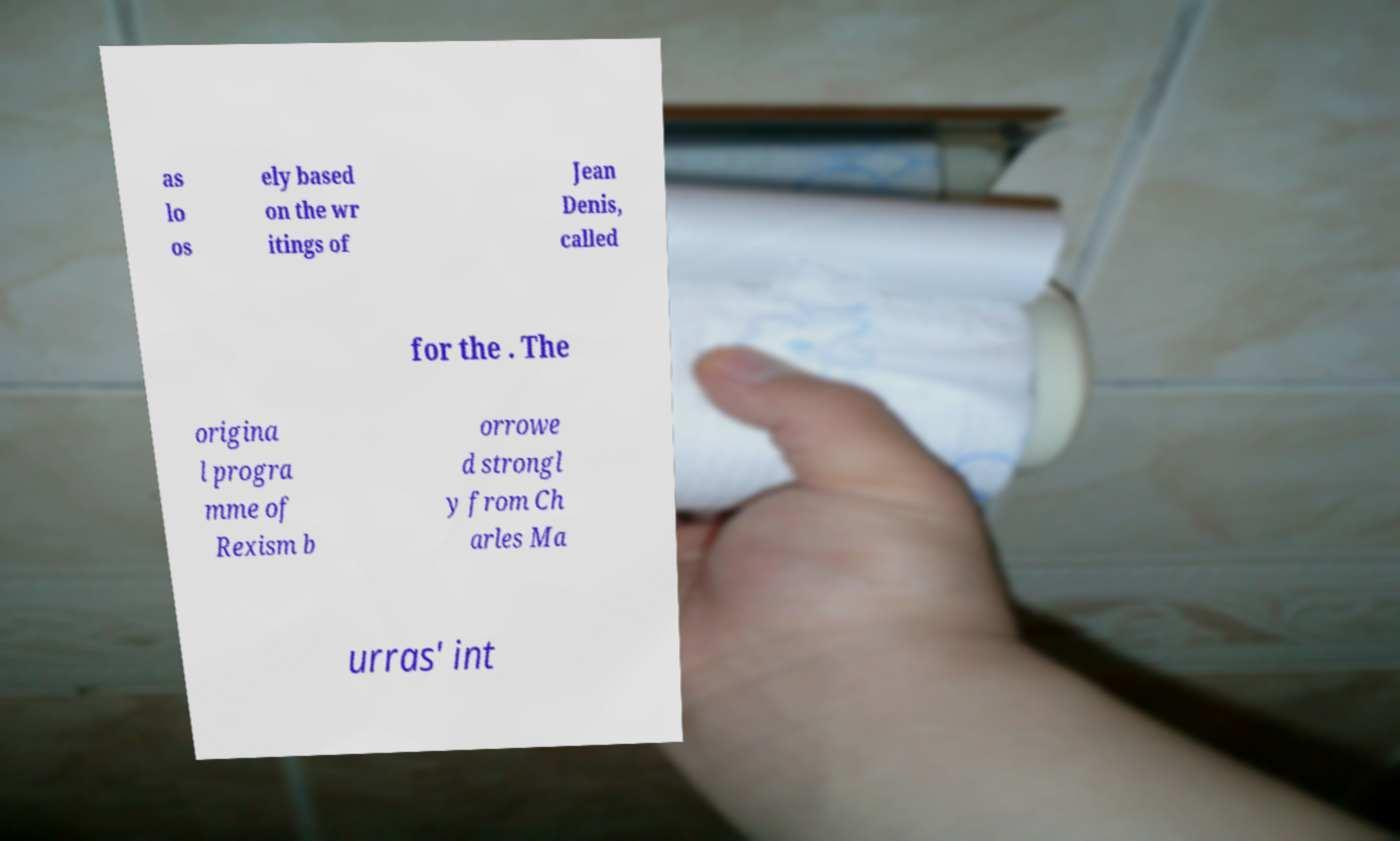Please identify and transcribe the text found in this image. as lo os ely based on the wr itings of Jean Denis, called for the . The origina l progra mme of Rexism b orrowe d strongl y from Ch arles Ma urras' int 